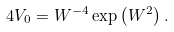<formula> <loc_0><loc_0><loc_500><loc_500>4 V _ { 0 } = W ^ { - 4 } \exp \left ( W ^ { 2 } \right ) .</formula> 